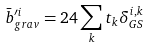Convert formula to latex. <formula><loc_0><loc_0><loc_500><loc_500>\bar { b } _ { g r a v } ^ { \prime i } = 2 4 \sum _ { k } t _ { k } \delta _ { G S } ^ { i , k }</formula> 